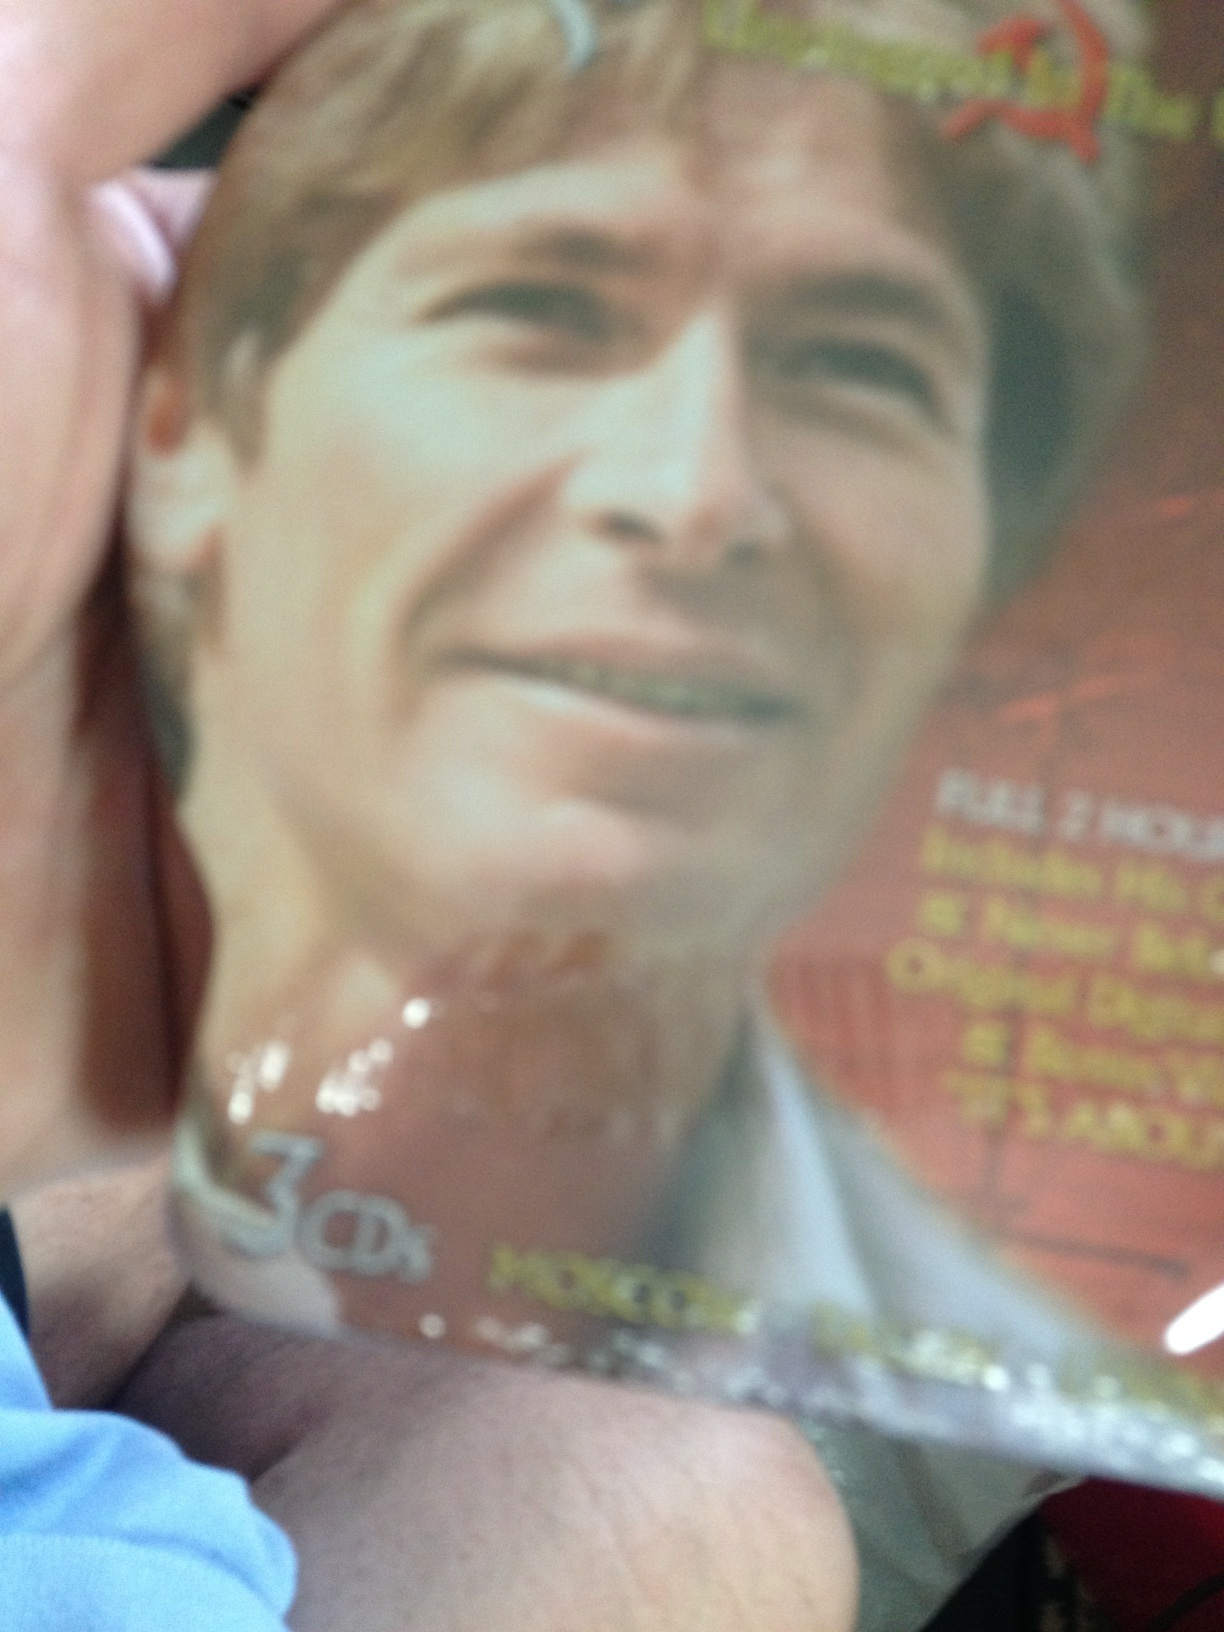What is the title of this CD? The title of the CD is not distinctly visible in the image provided. However, it appears to be a collection of songs or a compilation album, possibly featuring a male artist. To accurately determine the title, a clearer image or direct text reference would be necessary. 